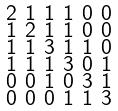Convert formula to latex. <formula><loc_0><loc_0><loc_500><loc_500>\begin{smallmatrix} 2 & 1 & 1 & 1 & 0 & 0 \\ 1 & 2 & 1 & 1 & 0 & 0 \\ 1 & 1 & 3 & 1 & 1 & 0 \\ 1 & 1 & 1 & 3 & 0 & 1 \\ 0 & 0 & 1 & 0 & 3 & 1 \\ 0 & 0 & 0 & 1 & 1 & 3 \end{smallmatrix}</formula> 